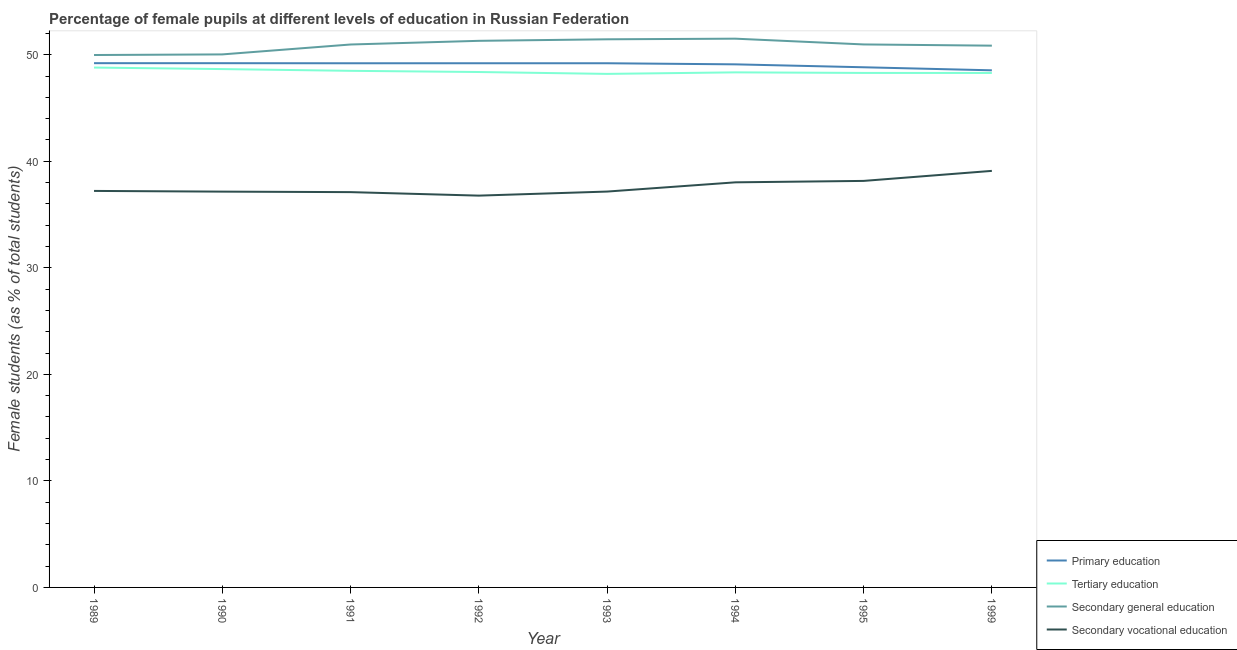How many different coloured lines are there?
Your response must be concise. 4. Does the line corresponding to percentage of female students in secondary vocational education intersect with the line corresponding to percentage of female students in secondary education?
Give a very brief answer. No. What is the percentage of female students in secondary vocational education in 1999?
Keep it short and to the point. 39.1. Across all years, what is the maximum percentage of female students in primary education?
Your answer should be compact. 49.21. Across all years, what is the minimum percentage of female students in secondary education?
Your answer should be compact. 49.97. In which year was the percentage of female students in secondary education maximum?
Your answer should be very brief. 1994. In which year was the percentage of female students in secondary education minimum?
Your answer should be very brief. 1989. What is the total percentage of female students in primary education in the graph?
Make the answer very short. 392.46. What is the difference between the percentage of female students in secondary vocational education in 1989 and that in 1995?
Your answer should be compact. -0.94. What is the difference between the percentage of female students in tertiary education in 1991 and the percentage of female students in secondary education in 1994?
Ensure brevity in your answer.  -3.02. What is the average percentage of female students in secondary education per year?
Ensure brevity in your answer.  50.88. In the year 1992, what is the difference between the percentage of female students in tertiary education and percentage of female students in secondary vocational education?
Ensure brevity in your answer.  11.6. In how many years, is the percentage of female students in secondary vocational education greater than 4 %?
Your answer should be compact. 8. What is the ratio of the percentage of female students in secondary vocational education in 1989 to that in 1994?
Offer a very short reply. 0.98. Is the percentage of female students in secondary education in 1991 less than that in 1992?
Keep it short and to the point. Yes. What is the difference between the highest and the second highest percentage of female students in secondary education?
Make the answer very short. 0.06. What is the difference between the highest and the lowest percentage of female students in primary education?
Your answer should be very brief. 0.67. Is the sum of the percentage of female students in tertiary education in 1993 and 1995 greater than the maximum percentage of female students in primary education across all years?
Provide a short and direct response. Yes. Is it the case that in every year, the sum of the percentage of female students in primary education and percentage of female students in tertiary education is greater than the percentage of female students in secondary education?
Give a very brief answer. Yes. Does the percentage of female students in primary education monotonically increase over the years?
Make the answer very short. No. How many years are there in the graph?
Your answer should be compact. 8. Are the values on the major ticks of Y-axis written in scientific E-notation?
Keep it short and to the point. No. How are the legend labels stacked?
Make the answer very short. Vertical. What is the title of the graph?
Keep it short and to the point. Percentage of female pupils at different levels of education in Russian Federation. What is the label or title of the Y-axis?
Provide a succinct answer. Female students (as % of total students). What is the Female students (as % of total students) of Primary education in 1989?
Keep it short and to the point. 49.21. What is the Female students (as % of total students) in Tertiary education in 1989?
Your response must be concise. 48.79. What is the Female students (as % of total students) of Secondary general education in 1989?
Ensure brevity in your answer.  49.97. What is the Female students (as % of total students) of Secondary vocational education in 1989?
Offer a very short reply. 37.21. What is the Female students (as % of total students) of Primary education in 1990?
Your answer should be very brief. 49.2. What is the Female students (as % of total students) of Tertiary education in 1990?
Your response must be concise. 48.65. What is the Female students (as % of total students) of Secondary general education in 1990?
Provide a succinct answer. 50.03. What is the Female students (as % of total students) of Secondary vocational education in 1990?
Make the answer very short. 37.15. What is the Female students (as % of total students) in Primary education in 1991?
Offer a terse response. 49.2. What is the Female students (as % of total students) in Tertiary education in 1991?
Provide a succinct answer. 48.49. What is the Female students (as % of total students) in Secondary general education in 1991?
Your response must be concise. 50.96. What is the Female students (as % of total students) of Secondary vocational education in 1991?
Keep it short and to the point. 37.1. What is the Female students (as % of total students) of Primary education in 1992?
Offer a terse response. 49.2. What is the Female students (as % of total students) in Tertiary education in 1992?
Offer a terse response. 48.38. What is the Female students (as % of total students) in Secondary general education in 1992?
Provide a succinct answer. 51.3. What is the Female students (as % of total students) in Secondary vocational education in 1992?
Your answer should be compact. 36.77. What is the Female students (as % of total students) in Primary education in 1993?
Provide a short and direct response. 49.2. What is the Female students (as % of total students) of Tertiary education in 1993?
Give a very brief answer. 48.2. What is the Female students (as % of total students) in Secondary general education in 1993?
Ensure brevity in your answer.  51.45. What is the Female students (as % of total students) of Secondary vocational education in 1993?
Make the answer very short. 37.15. What is the Female students (as % of total students) in Primary education in 1994?
Provide a succinct answer. 49.1. What is the Female students (as % of total students) in Tertiary education in 1994?
Offer a very short reply. 48.34. What is the Female students (as % of total students) of Secondary general education in 1994?
Offer a terse response. 51.51. What is the Female students (as % of total students) of Secondary vocational education in 1994?
Ensure brevity in your answer.  38.02. What is the Female students (as % of total students) of Primary education in 1995?
Your answer should be compact. 48.82. What is the Female students (as % of total students) of Tertiary education in 1995?
Offer a terse response. 48.29. What is the Female students (as % of total students) in Secondary general education in 1995?
Give a very brief answer. 50.96. What is the Female students (as % of total students) of Secondary vocational education in 1995?
Ensure brevity in your answer.  38.16. What is the Female students (as % of total students) in Primary education in 1999?
Your answer should be very brief. 48.54. What is the Female students (as % of total students) of Tertiary education in 1999?
Offer a terse response. 48.29. What is the Female students (as % of total students) in Secondary general education in 1999?
Ensure brevity in your answer.  50.85. What is the Female students (as % of total students) in Secondary vocational education in 1999?
Give a very brief answer. 39.1. Across all years, what is the maximum Female students (as % of total students) in Primary education?
Offer a very short reply. 49.21. Across all years, what is the maximum Female students (as % of total students) in Tertiary education?
Your answer should be very brief. 48.79. Across all years, what is the maximum Female students (as % of total students) in Secondary general education?
Keep it short and to the point. 51.51. Across all years, what is the maximum Female students (as % of total students) in Secondary vocational education?
Provide a short and direct response. 39.1. Across all years, what is the minimum Female students (as % of total students) in Primary education?
Make the answer very short. 48.54. Across all years, what is the minimum Female students (as % of total students) in Tertiary education?
Your answer should be very brief. 48.2. Across all years, what is the minimum Female students (as % of total students) of Secondary general education?
Make the answer very short. 49.97. Across all years, what is the minimum Female students (as % of total students) of Secondary vocational education?
Offer a very short reply. 36.77. What is the total Female students (as % of total students) in Primary education in the graph?
Ensure brevity in your answer.  392.46. What is the total Female students (as % of total students) in Tertiary education in the graph?
Your answer should be very brief. 387.43. What is the total Female students (as % of total students) in Secondary general education in the graph?
Your answer should be very brief. 407.03. What is the total Female students (as % of total students) of Secondary vocational education in the graph?
Offer a terse response. 300.67. What is the difference between the Female students (as % of total students) in Primary education in 1989 and that in 1990?
Your response must be concise. 0. What is the difference between the Female students (as % of total students) in Tertiary education in 1989 and that in 1990?
Your answer should be very brief. 0.14. What is the difference between the Female students (as % of total students) in Secondary general education in 1989 and that in 1990?
Give a very brief answer. -0.06. What is the difference between the Female students (as % of total students) in Secondary vocational education in 1989 and that in 1990?
Give a very brief answer. 0.07. What is the difference between the Female students (as % of total students) of Primary education in 1989 and that in 1991?
Your answer should be compact. 0.01. What is the difference between the Female students (as % of total students) in Tertiary education in 1989 and that in 1991?
Give a very brief answer. 0.31. What is the difference between the Female students (as % of total students) in Secondary general education in 1989 and that in 1991?
Offer a terse response. -0.99. What is the difference between the Female students (as % of total students) of Secondary vocational education in 1989 and that in 1991?
Make the answer very short. 0.11. What is the difference between the Female students (as % of total students) of Primary education in 1989 and that in 1992?
Your answer should be compact. 0.01. What is the difference between the Female students (as % of total students) of Tertiary education in 1989 and that in 1992?
Provide a short and direct response. 0.42. What is the difference between the Female students (as % of total students) in Secondary general education in 1989 and that in 1992?
Make the answer very short. -1.33. What is the difference between the Female students (as % of total students) of Secondary vocational education in 1989 and that in 1992?
Make the answer very short. 0.44. What is the difference between the Female students (as % of total students) in Primary education in 1989 and that in 1993?
Keep it short and to the point. 0.01. What is the difference between the Female students (as % of total students) in Tertiary education in 1989 and that in 1993?
Give a very brief answer. 0.59. What is the difference between the Female students (as % of total students) of Secondary general education in 1989 and that in 1993?
Keep it short and to the point. -1.48. What is the difference between the Female students (as % of total students) in Secondary vocational education in 1989 and that in 1993?
Keep it short and to the point. 0.06. What is the difference between the Female students (as % of total students) in Primary education in 1989 and that in 1994?
Your response must be concise. 0.11. What is the difference between the Female students (as % of total students) of Tertiary education in 1989 and that in 1994?
Offer a very short reply. 0.45. What is the difference between the Female students (as % of total students) in Secondary general education in 1989 and that in 1994?
Keep it short and to the point. -1.53. What is the difference between the Female students (as % of total students) of Secondary vocational education in 1989 and that in 1994?
Provide a succinct answer. -0.81. What is the difference between the Female students (as % of total students) of Primary education in 1989 and that in 1995?
Give a very brief answer. 0.38. What is the difference between the Female students (as % of total students) in Tertiary education in 1989 and that in 1995?
Provide a succinct answer. 0.5. What is the difference between the Female students (as % of total students) of Secondary general education in 1989 and that in 1995?
Provide a short and direct response. -0.99. What is the difference between the Female students (as % of total students) in Secondary vocational education in 1989 and that in 1995?
Provide a succinct answer. -0.94. What is the difference between the Female students (as % of total students) of Primary education in 1989 and that in 1999?
Offer a terse response. 0.67. What is the difference between the Female students (as % of total students) in Tertiary education in 1989 and that in 1999?
Offer a terse response. 0.51. What is the difference between the Female students (as % of total students) in Secondary general education in 1989 and that in 1999?
Your answer should be compact. -0.88. What is the difference between the Female students (as % of total students) of Secondary vocational education in 1989 and that in 1999?
Give a very brief answer. -1.88. What is the difference between the Female students (as % of total students) in Primary education in 1990 and that in 1991?
Your response must be concise. 0.01. What is the difference between the Female students (as % of total students) in Tertiary education in 1990 and that in 1991?
Your response must be concise. 0.16. What is the difference between the Female students (as % of total students) of Secondary general education in 1990 and that in 1991?
Provide a succinct answer. -0.93. What is the difference between the Female students (as % of total students) in Secondary vocational education in 1990 and that in 1991?
Make the answer very short. 0.05. What is the difference between the Female students (as % of total students) in Primary education in 1990 and that in 1992?
Your answer should be compact. 0. What is the difference between the Female students (as % of total students) in Tertiary education in 1990 and that in 1992?
Offer a very short reply. 0.28. What is the difference between the Female students (as % of total students) of Secondary general education in 1990 and that in 1992?
Make the answer very short. -1.27. What is the difference between the Female students (as % of total students) of Secondary vocational education in 1990 and that in 1992?
Provide a succinct answer. 0.38. What is the difference between the Female students (as % of total students) of Primary education in 1990 and that in 1993?
Your answer should be very brief. 0.01. What is the difference between the Female students (as % of total students) of Tertiary education in 1990 and that in 1993?
Make the answer very short. 0.45. What is the difference between the Female students (as % of total students) of Secondary general education in 1990 and that in 1993?
Your answer should be compact. -1.42. What is the difference between the Female students (as % of total students) in Secondary vocational education in 1990 and that in 1993?
Give a very brief answer. -0.01. What is the difference between the Female students (as % of total students) in Primary education in 1990 and that in 1994?
Your response must be concise. 0.11. What is the difference between the Female students (as % of total students) of Tertiary education in 1990 and that in 1994?
Your answer should be very brief. 0.31. What is the difference between the Female students (as % of total students) of Secondary general education in 1990 and that in 1994?
Offer a terse response. -1.48. What is the difference between the Female students (as % of total students) in Secondary vocational education in 1990 and that in 1994?
Ensure brevity in your answer.  -0.87. What is the difference between the Female students (as % of total students) in Primary education in 1990 and that in 1995?
Your response must be concise. 0.38. What is the difference between the Female students (as % of total students) in Tertiary education in 1990 and that in 1995?
Ensure brevity in your answer.  0.36. What is the difference between the Female students (as % of total students) of Secondary general education in 1990 and that in 1995?
Give a very brief answer. -0.94. What is the difference between the Female students (as % of total students) in Secondary vocational education in 1990 and that in 1995?
Keep it short and to the point. -1.01. What is the difference between the Female students (as % of total students) of Primary education in 1990 and that in 1999?
Your answer should be compact. 0.67. What is the difference between the Female students (as % of total students) of Tertiary education in 1990 and that in 1999?
Keep it short and to the point. 0.36. What is the difference between the Female students (as % of total students) of Secondary general education in 1990 and that in 1999?
Give a very brief answer. -0.82. What is the difference between the Female students (as % of total students) in Secondary vocational education in 1990 and that in 1999?
Give a very brief answer. -1.95. What is the difference between the Female students (as % of total students) of Primary education in 1991 and that in 1992?
Provide a short and direct response. -0. What is the difference between the Female students (as % of total students) in Tertiary education in 1991 and that in 1992?
Make the answer very short. 0.11. What is the difference between the Female students (as % of total students) in Secondary general education in 1991 and that in 1992?
Provide a short and direct response. -0.34. What is the difference between the Female students (as % of total students) in Secondary vocational education in 1991 and that in 1992?
Your response must be concise. 0.33. What is the difference between the Female students (as % of total students) of Primary education in 1991 and that in 1993?
Give a very brief answer. -0. What is the difference between the Female students (as % of total students) of Tertiary education in 1991 and that in 1993?
Offer a very short reply. 0.29. What is the difference between the Female students (as % of total students) in Secondary general education in 1991 and that in 1993?
Offer a very short reply. -0.49. What is the difference between the Female students (as % of total students) of Secondary vocational education in 1991 and that in 1993?
Offer a terse response. -0.05. What is the difference between the Female students (as % of total students) of Primary education in 1991 and that in 1994?
Provide a succinct answer. 0.1. What is the difference between the Female students (as % of total students) of Tertiary education in 1991 and that in 1994?
Provide a succinct answer. 0.14. What is the difference between the Female students (as % of total students) of Secondary general education in 1991 and that in 1994?
Provide a short and direct response. -0.55. What is the difference between the Female students (as % of total students) in Secondary vocational education in 1991 and that in 1994?
Your response must be concise. -0.92. What is the difference between the Female students (as % of total students) of Primary education in 1991 and that in 1995?
Your response must be concise. 0.38. What is the difference between the Female students (as % of total students) in Tertiary education in 1991 and that in 1995?
Offer a terse response. 0.2. What is the difference between the Female students (as % of total students) of Secondary general education in 1991 and that in 1995?
Provide a short and direct response. -0.01. What is the difference between the Female students (as % of total students) in Secondary vocational education in 1991 and that in 1995?
Offer a very short reply. -1.05. What is the difference between the Female students (as % of total students) in Primary education in 1991 and that in 1999?
Offer a very short reply. 0.66. What is the difference between the Female students (as % of total students) of Tertiary education in 1991 and that in 1999?
Keep it short and to the point. 0.2. What is the difference between the Female students (as % of total students) of Secondary general education in 1991 and that in 1999?
Give a very brief answer. 0.11. What is the difference between the Female students (as % of total students) in Secondary vocational education in 1991 and that in 1999?
Your answer should be compact. -1.99. What is the difference between the Female students (as % of total students) in Tertiary education in 1992 and that in 1993?
Your response must be concise. 0.18. What is the difference between the Female students (as % of total students) of Secondary general education in 1992 and that in 1993?
Keep it short and to the point. -0.14. What is the difference between the Female students (as % of total students) in Secondary vocational education in 1992 and that in 1993?
Make the answer very short. -0.38. What is the difference between the Female students (as % of total students) of Primary education in 1992 and that in 1994?
Your answer should be very brief. 0.1. What is the difference between the Female students (as % of total students) of Tertiary education in 1992 and that in 1994?
Make the answer very short. 0.03. What is the difference between the Female students (as % of total students) of Secondary general education in 1992 and that in 1994?
Your answer should be compact. -0.2. What is the difference between the Female students (as % of total students) of Secondary vocational education in 1992 and that in 1994?
Your response must be concise. -1.25. What is the difference between the Female students (as % of total students) in Primary education in 1992 and that in 1995?
Provide a short and direct response. 0.38. What is the difference between the Female students (as % of total students) in Tertiary education in 1992 and that in 1995?
Provide a short and direct response. 0.09. What is the difference between the Female students (as % of total students) of Secondary general education in 1992 and that in 1995?
Your answer should be compact. 0.34. What is the difference between the Female students (as % of total students) of Secondary vocational education in 1992 and that in 1995?
Provide a succinct answer. -1.38. What is the difference between the Female students (as % of total students) of Primary education in 1992 and that in 1999?
Your response must be concise. 0.66. What is the difference between the Female students (as % of total students) in Tertiary education in 1992 and that in 1999?
Make the answer very short. 0.09. What is the difference between the Female students (as % of total students) in Secondary general education in 1992 and that in 1999?
Offer a terse response. 0.45. What is the difference between the Female students (as % of total students) of Secondary vocational education in 1992 and that in 1999?
Provide a succinct answer. -2.32. What is the difference between the Female students (as % of total students) in Primary education in 1993 and that in 1994?
Your response must be concise. 0.1. What is the difference between the Female students (as % of total students) in Tertiary education in 1993 and that in 1994?
Provide a short and direct response. -0.14. What is the difference between the Female students (as % of total students) of Secondary general education in 1993 and that in 1994?
Your answer should be compact. -0.06. What is the difference between the Female students (as % of total students) of Secondary vocational education in 1993 and that in 1994?
Offer a terse response. -0.87. What is the difference between the Female students (as % of total students) of Primary education in 1993 and that in 1995?
Provide a succinct answer. 0.38. What is the difference between the Female students (as % of total students) of Tertiary education in 1993 and that in 1995?
Keep it short and to the point. -0.09. What is the difference between the Female students (as % of total students) of Secondary general education in 1993 and that in 1995?
Your response must be concise. 0.48. What is the difference between the Female students (as % of total students) of Secondary vocational education in 1993 and that in 1995?
Your answer should be very brief. -1. What is the difference between the Female students (as % of total students) in Primary education in 1993 and that in 1999?
Your response must be concise. 0.66. What is the difference between the Female students (as % of total students) of Tertiary education in 1993 and that in 1999?
Give a very brief answer. -0.09. What is the difference between the Female students (as % of total students) of Secondary general education in 1993 and that in 1999?
Your answer should be very brief. 0.6. What is the difference between the Female students (as % of total students) in Secondary vocational education in 1993 and that in 1999?
Your answer should be very brief. -1.94. What is the difference between the Female students (as % of total students) in Primary education in 1994 and that in 1995?
Make the answer very short. 0.27. What is the difference between the Female students (as % of total students) of Tertiary education in 1994 and that in 1995?
Your response must be concise. 0.05. What is the difference between the Female students (as % of total students) of Secondary general education in 1994 and that in 1995?
Ensure brevity in your answer.  0.54. What is the difference between the Female students (as % of total students) of Secondary vocational education in 1994 and that in 1995?
Offer a very short reply. -0.13. What is the difference between the Female students (as % of total students) of Primary education in 1994 and that in 1999?
Ensure brevity in your answer.  0.56. What is the difference between the Female students (as % of total students) in Tertiary education in 1994 and that in 1999?
Offer a very short reply. 0.06. What is the difference between the Female students (as % of total students) in Secondary general education in 1994 and that in 1999?
Keep it short and to the point. 0.66. What is the difference between the Female students (as % of total students) in Secondary vocational education in 1994 and that in 1999?
Ensure brevity in your answer.  -1.08. What is the difference between the Female students (as % of total students) of Primary education in 1995 and that in 1999?
Provide a short and direct response. 0.29. What is the difference between the Female students (as % of total students) of Tertiary education in 1995 and that in 1999?
Provide a short and direct response. 0. What is the difference between the Female students (as % of total students) in Secondary general education in 1995 and that in 1999?
Make the answer very short. 0.11. What is the difference between the Female students (as % of total students) of Secondary vocational education in 1995 and that in 1999?
Your answer should be very brief. -0.94. What is the difference between the Female students (as % of total students) in Primary education in 1989 and the Female students (as % of total students) in Tertiary education in 1990?
Give a very brief answer. 0.56. What is the difference between the Female students (as % of total students) of Primary education in 1989 and the Female students (as % of total students) of Secondary general education in 1990?
Your answer should be compact. -0.82. What is the difference between the Female students (as % of total students) in Primary education in 1989 and the Female students (as % of total students) in Secondary vocational education in 1990?
Provide a succinct answer. 12.06. What is the difference between the Female students (as % of total students) of Tertiary education in 1989 and the Female students (as % of total students) of Secondary general education in 1990?
Make the answer very short. -1.23. What is the difference between the Female students (as % of total students) of Tertiary education in 1989 and the Female students (as % of total students) of Secondary vocational education in 1990?
Offer a very short reply. 11.65. What is the difference between the Female students (as % of total students) in Secondary general education in 1989 and the Female students (as % of total students) in Secondary vocational education in 1990?
Provide a short and direct response. 12.82. What is the difference between the Female students (as % of total students) in Primary education in 1989 and the Female students (as % of total students) in Tertiary education in 1991?
Your answer should be very brief. 0.72. What is the difference between the Female students (as % of total students) of Primary education in 1989 and the Female students (as % of total students) of Secondary general education in 1991?
Make the answer very short. -1.75. What is the difference between the Female students (as % of total students) of Primary education in 1989 and the Female students (as % of total students) of Secondary vocational education in 1991?
Offer a very short reply. 12.1. What is the difference between the Female students (as % of total students) in Tertiary education in 1989 and the Female students (as % of total students) in Secondary general education in 1991?
Your answer should be very brief. -2.16. What is the difference between the Female students (as % of total students) of Tertiary education in 1989 and the Female students (as % of total students) of Secondary vocational education in 1991?
Offer a very short reply. 11.69. What is the difference between the Female students (as % of total students) in Secondary general education in 1989 and the Female students (as % of total students) in Secondary vocational education in 1991?
Your answer should be very brief. 12.87. What is the difference between the Female students (as % of total students) of Primary education in 1989 and the Female students (as % of total students) of Tertiary education in 1992?
Keep it short and to the point. 0.83. What is the difference between the Female students (as % of total students) in Primary education in 1989 and the Female students (as % of total students) in Secondary general education in 1992?
Provide a succinct answer. -2.1. What is the difference between the Female students (as % of total students) in Primary education in 1989 and the Female students (as % of total students) in Secondary vocational education in 1992?
Keep it short and to the point. 12.43. What is the difference between the Female students (as % of total students) of Tertiary education in 1989 and the Female students (as % of total students) of Secondary general education in 1992?
Your response must be concise. -2.51. What is the difference between the Female students (as % of total students) in Tertiary education in 1989 and the Female students (as % of total students) in Secondary vocational education in 1992?
Give a very brief answer. 12.02. What is the difference between the Female students (as % of total students) of Secondary general education in 1989 and the Female students (as % of total students) of Secondary vocational education in 1992?
Make the answer very short. 13.2. What is the difference between the Female students (as % of total students) in Primary education in 1989 and the Female students (as % of total students) in Tertiary education in 1993?
Provide a short and direct response. 1.01. What is the difference between the Female students (as % of total students) in Primary education in 1989 and the Female students (as % of total students) in Secondary general education in 1993?
Give a very brief answer. -2.24. What is the difference between the Female students (as % of total students) of Primary education in 1989 and the Female students (as % of total students) of Secondary vocational education in 1993?
Provide a succinct answer. 12.05. What is the difference between the Female students (as % of total students) of Tertiary education in 1989 and the Female students (as % of total students) of Secondary general education in 1993?
Your answer should be compact. -2.65. What is the difference between the Female students (as % of total students) in Tertiary education in 1989 and the Female students (as % of total students) in Secondary vocational education in 1993?
Provide a succinct answer. 11.64. What is the difference between the Female students (as % of total students) of Secondary general education in 1989 and the Female students (as % of total students) of Secondary vocational education in 1993?
Offer a very short reply. 12.82. What is the difference between the Female students (as % of total students) of Primary education in 1989 and the Female students (as % of total students) of Tertiary education in 1994?
Your answer should be very brief. 0.86. What is the difference between the Female students (as % of total students) of Primary education in 1989 and the Female students (as % of total students) of Secondary general education in 1994?
Offer a very short reply. -2.3. What is the difference between the Female students (as % of total students) of Primary education in 1989 and the Female students (as % of total students) of Secondary vocational education in 1994?
Ensure brevity in your answer.  11.18. What is the difference between the Female students (as % of total students) in Tertiary education in 1989 and the Female students (as % of total students) in Secondary general education in 1994?
Keep it short and to the point. -2.71. What is the difference between the Female students (as % of total students) of Tertiary education in 1989 and the Female students (as % of total students) of Secondary vocational education in 1994?
Your answer should be very brief. 10.77. What is the difference between the Female students (as % of total students) in Secondary general education in 1989 and the Female students (as % of total students) in Secondary vocational education in 1994?
Provide a succinct answer. 11.95. What is the difference between the Female students (as % of total students) in Primary education in 1989 and the Female students (as % of total students) in Tertiary education in 1995?
Offer a terse response. 0.92. What is the difference between the Female students (as % of total students) in Primary education in 1989 and the Female students (as % of total students) in Secondary general education in 1995?
Make the answer very short. -1.76. What is the difference between the Female students (as % of total students) of Primary education in 1989 and the Female students (as % of total students) of Secondary vocational education in 1995?
Make the answer very short. 11.05. What is the difference between the Female students (as % of total students) in Tertiary education in 1989 and the Female students (as % of total students) in Secondary general education in 1995?
Offer a terse response. -2.17. What is the difference between the Female students (as % of total students) in Tertiary education in 1989 and the Female students (as % of total students) in Secondary vocational education in 1995?
Keep it short and to the point. 10.64. What is the difference between the Female students (as % of total students) of Secondary general education in 1989 and the Female students (as % of total students) of Secondary vocational education in 1995?
Provide a short and direct response. 11.82. What is the difference between the Female students (as % of total students) of Primary education in 1989 and the Female students (as % of total students) of Tertiary education in 1999?
Make the answer very short. 0.92. What is the difference between the Female students (as % of total students) in Primary education in 1989 and the Female students (as % of total students) in Secondary general education in 1999?
Offer a very short reply. -1.64. What is the difference between the Female students (as % of total students) in Primary education in 1989 and the Female students (as % of total students) in Secondary vocational education in 1999?
Offer a terse response. 10.11. What is the difference between the Female students (as % of total students) in Tertiary education in 1989 and the Female students (as % of total students) in Secondary general education in 1999?
Provide a short and direct response. -2.06. What is the difference between the Female students (as % of total students) in Tertiary education in 1989 and the Female students (as % of total students) in Secondary vocational education in 1999?
Offer a terse response. 9.7. What is the difference between the Female students (as % of total students) in Secondary general education in 1989 and the Female students (as % of total students) in Secondary vocational education in 1999?
Give a very brief answer. 10.87. What is the difference between the Female students (as % of total students) of Primary education in 1990 and the Female students (as % of total students) of Tertiary education in 1991?
Ensure brevity in your answer.  0.72. What is the difference between the Female students (as % of total students) of Primary education in 1990 and the Female students (as % of total students) of Secondary general education in 1991?
Keep it short and to the point. -1.75. What is the difference between the Female students (as % of total students) of Primary education in 1990 and the Female students (as % of total students) of Secondary vocational education in 1991?
Ensure brevity in your answer.  12.1. What is the difference between the Female students (as % of total students) of Tertiary education in 1990 and the Female students (as % of total students) of Secondary general education in 1991?
Keep it short and to the point. -2.31. What is the difference between the Female students (as % of total students) in Tertiary education in 1990 and the Female students (as % of total students) in Secondary vocational education in 1991?
Keep it short and to the point. 11.55. What is the difference between the Female students (as % of total students) in Secondary general education in 1990 and the Female students (as % of total students) in Secondary vocational education in 1991?
Give a very brief answer. 12.93. What is the difference between the Female students (as % of total students) of Primary education in 1990 and the Female students (as % of total students) of Tertiary education in 1992?
Your response must be concise. 0.83. What is the difference between the Female students (as % of total students) in Primary education in 1990 and the Female students (as % of total students) in Secondary vocational education in 1992?
Your answer should be very brief. 12.43. What is the difference between the Female students (as % of total students) of Tertiary education in 1990 and the Female students (as % of total students) of Secondary general education in 1992?
Ensure brevity in your answer.  -2.65. What is the difference between the Female students (as % of total students) of Tertiary education in 1990 and the Female students (as % of total students) of Secondary vocational education in 1992?
Offer a very short reply. 11.88. What is the difference between the Female students (as % of total students) of Secondary general education in 1990 and the Female students (as % of total students) of Secondary vocational education in 1992?
Provide a succinct answer. 13.26. What is the difference between the Female students (as % of total students) in Primary education in 1990 and the Female students (as % of total students) in Secondary general education in 1993?
Ensure brevity in your answer.  -2.24. What is the difference between the Female students (as % of total students) of Primary education in 1990 and the Female students (as % of total students) of Secondary vocational education in 1993?
Provide a short and direct response. 12.05. What is the difference between the Female students (as % of total students) of Tertiary education in 1990 and the Female students (as % of total students) of Secondary general education in 1993?
Offer a terse response. -2.8. What is the difference between the Female students (as % of total students) of Tertiary education in 1990 and the Female students (as % of total students) of Secondary vocational education in 1993?
Give a very brief answer. 11.5. What is the difference between the Female students (as % of total students) of Secondary general education in 1990 and the Female students (as % of total students) of Secondary vocational education in 1993?
Give a very brief answer. 12.87. What is the difference between the Female students (as % of total students) in Primary education in 1990 and the Female students (as % of total students) in Tertiary education in 1994?
Your response must be concise. 0.86. What is the difference between the Female students (as % of total students) in Primary education in 1990 and the Female students (as % of total students) in Secondary general education in 1994?
Keep it short and to the point. -2.3. What is the difference between the Female students (as % of total students) in Primary education in 1990 and the Female students (as % of total students) in Secondary vocational education in 1994?
Your answer should be compact. 11.18. What is the difference between the Female students (as % of total students) in Tertiary education in 1990 and the Female students (as % of total students) in Secondary general education in 1994?
Your answer should be very brief. -2.85. What is the difference between the Female students (as % of total students) in Tertiary education in 1990 and the Female students (as % of total students) in Secondary vocational education in 1994?
Your answer should be very brief. 10.63. What is the difference between the Female students (as % of total students) of Secondary general education in 1990 and the Female students (as % of total students) of Secondary vocational education in 1994?
Provide a succinct answer. 12.01. What is the difference between the Female students (as % of total students) of Primary education in 1990 and the Female students (as % of total students) of Tertiary education in 1995?
Offer a very short reply. 0.91. What is the difference between the Female students (as % of total students) of Primary education in 1990 and the Female students (as % of total students) of Secondary general education in 1995?
Your answer should be very brief. -1.76. What is the difference between the Female students (as % of total students) of Primary education in 1990 and the Female students (as % of total students) of Secondary vocational education in 1995?
Your answer should be very brief. 11.05. What is the difference between the Female students (as % of total students) in Tertiary education in 1990 and the Female students (as % of total students) in Secondary general education in 1995?
Your response must be concise. -2.31. What is the difference between the Female students (as % of total students) in Tertiary education in 1990 and the Female students (as % of total students) in Secondary vocational education in 1995?
Offer a very short reply. 10.5. What is the difference between the Female students (as % of total students) in Secondary general education in 1990 and the Female students (as % of total students) in Secondary vocational education in 1995?
Offer a terse response. 11.87. What is the difference between the Female students (as % of total students) in Primary education in 1990 and the Female students (as % of total students) in Tertiary education in 1999?
Make the answer very short. 0.92. What is the difference between the Female students (as % of total students) in Primary education in 1990 and the Female students (as % of total students) in Secondary general education in 1999?
Provide a short and direct response. -1.65. What is the difference between the Female students (as % of total students) of Primary education in 1990 and the Female students (as % of total students) of Secondary vocational education in 1999?
Offer a terse response. 10.11. What is the difference between the Female students (as % of total students) in Tertiary education in 1990 and the Female students (as % of total students) in Secondary general education in 1999?
Give a very brief answer. -2.2. What is the difference between the Female students (as % of total students) of Tertiary education in 1990 and the Female students (as % of total students) of Secondary vocational education in 1999?
Give a very brief answer. 9.55. What is the difference between the Female students (as % of total students) of Secondary general education in 1990 and the Female students (as % of total students) of Secondary vocational education in 1999?
Provide a succinct answer. 10.93. What is the difference between the Female students (as % of total students) of Primary education in 1991 and the Female students (as % of total students) of Tertiary education in 1992?
Offer a terse response. 0.82. What is the difference between the Female students (as % of total students) of Primary education in 1991 and the Female students (as % of total students) of Secondary general education in 1992?
Offer a terse response. -2.11. What is the difference between the Female students (as % of total students) of Primary education in 1991 and the Female students (as % of total students) of Secondary vocational education in 1992?
Make the answer very short. 12.42. What is the difference between the Female students (as % of total students) of Tertiary education in 1991 and the Female students (as % of total students) of Secondary general education in 1992?
Keep it short and to the point. -2.82. What is the difference between the Female students (as % of total students) in Tertiary education in 1991 and the Female students (as % of total students) in Secondary vocational education in 1992?
Provide a succinct answer. 11.71. What is the difference between the Female students (as % of total students) in Secondary general education in 1991 and the Female students (as % of total students) in Secondary vocational education in 1992?
Offer a terse response. 14.19. What is the difference between the Female students (as % of total students) in Primary education in 1991 and the Female students (as % of total students) in Tertiary education in 1993?
Make the answer very short. 1. What is the difference between the Female students (as % of total students) of Primary education in 1991 and the Female students (as % of total students) of Secondary general education in 1993?
Give a very brief answer. -2.25. What is the difference between the Female students (as % of total students) in Primary education in 1991 and the Female students (as % of total students) in Secondary vocational education in 1993?
Keep it short and to the point. 12.04. What is the difference between the Female students (as % of total students) in Tertiary education in 1991 and the Female students (as % of total students) in Secondary general education in 1993?
Provide a succinct answer. -2.96. What is the difference between the Female students (as % of total students) of Tertiary education in 1991 and the Female students (as % of total students) of Secondary vocational education in 1993?
Provide a short and direct response. 11.33. What is the difference between the Female students (as % of total students) of Secondary general education in 1991 and the Female students (as % of total students) of Secondary vocational education in 1993?
Offer a terse response. 13.8. What is the difference between the Female students (as % of total students) in Primary education in 1991 and the Female students (as % of total students) in Tertiary education in 1994?
Provide a succinct answer. 0.85. What is the difference between the Female students (as % of total students) in Primary education in 1991 and the Female students (as % of total students) in Secondary general education in 1994?
Your answer should be compact. -2.31. What is the difference between the Female students (as % of total students) of Primary education in 1991 and the Female students (as % of total students) of Secondary vocational education in 1994?
Give a very brief answer. 11.18. What is the difference between the Female students (as % of total students) of Tertiary education in 1991 and the Female students (as % of total students) of Secondary general education in 1994?
Your answer should be compact. -3.02. What is the difference between the Female students (as % of total students) in Tertiary education in 1991 and the Female students (as % of total students) in Secondary vocational education in 1994?
Offer a terse response. 10.47. What is the difference between the Female students (as % of total students) of Secondary general education in 1991 and the Female students (as % of total students) of Secondary vocational education in 1994?
Provide a succinct answer. 12.94. What is the difference between the Female students (as % of total students) of Primary education in 1991 and the Female students (as % of total students) of Tertiary education in 1995?
Offer a very short reply. 0.91. What is the difference between the Female students (as % of total students) in Primary education in 1991 and the Female students (as % of total students) in Secondary general education in 1995?
Ensure brevity in your answer.  -1.77. What is the difference between the Female students (as % of total students) of Primary education in 1991 and the Female students (as % of total students) of Secondary vocational education in 1995?
Provide a succinct answer. 11.04. What is the difference between the Female students (as % of total students) in Tertiary education in 1991 and the Female students (as % of total students) in Secondary general education in 1995?
Provide a succinct answer. -2.48. What is the difference between the Female students (as % of total students) of Tertiary education in 1991 and the Female students (as % of total students) of Secondary vocational education in 1995?
Ensure brevity in your answer.  10.33. What is the difference between the Female students (as % of total students) in Secondary general education in 1991 and the Female students (as % of total students) in Secondary vocational education in 1995?
Your answer should be compact. 12.8. What is the difference between the Female students (as % of total students) of Primary education in 1991 and the Female students (as % of total students) of Tertiary education in 1999?
Your answer should be compact. 0.91. What is the difference between the Female students (as % of total students) of Primary education in 1991 and the Female students (as % of total students) of Secondary general education in 1999?
Provide a short and direct response. -1.65. What is the difference between the Female students (as % of total students) of Primary education in 1991 and the Female students (as % of total students) of Secondary vocational education in 1999?
Your answer should be very brief. 10.1. What is the difference between the Female students (as % of total students) in Tertiary education in 1991 and the Female students (as % of total students) in Secondary general education in 1999?
Provide a succinct answer. -2.36. What is the difference between the Female students (as % of total students) of Tertiary education in 1991 and the Female students (as % of total students) of Secondary vocational education in 1999?
Ensure brevity in your answer.  9.39. What is the difference between the Female students (as % of total students) of Secondary general education in 1991 and the Female students (as % of total students) of Secondary vocational education in 1999?
Keep it short and to the point. 11.86. What is the difference between the Female students (as % of total students) in Primary education in 1992 and the Female students (as % of total students) in Tertiary education in 1993?
Provide a short and direct response. 1. What is the difference between the Female students (as % of total students) in Primary education in 1992 and the Female students (as % of total students) in Secondary general education in 1993?
Make the answer very short. -2.25. What is the difference between the Female students (as % of total students) of Primary education in 1992 and the Female students (as % of total students) of Secondary vocational education in 1993?
Provide a short and direct response. 12.04. What is the difference between the Female students (as % of total students) in Tertiary education in 1992 and the Female students (as % of total students) in Secondary general education in 1993?
Keep it short and to the point. -3.07. What is the difference between the Female students (as % of total students) of Tertiary education in 1992 and the Female students (as % of total students) of Secondary vocational education in 1993?
Provide a short and direct response. 11.22. What is the difference between the Female students (as % of total students) of Secondary general education in 1992 and the Female students (as % of total students) of Secondary vocational education in 1993?
Your answer should be compact. 14.15. What is the difference between the Female students (as % of total students) of Primary education in 1992 and the Female students (as % of total students) of Tertiary education in 1994?
Offer a very short reply. 0.86. What is the difference between the Female students (as % of total students) in Primary education in 1992 and the Female students (as % of total students) in Secondary general education in 1994?
Your answer should be compact. -2.31. What is the difference between the Female students (as % of total students) in Primary education in 1992 and the Female students (as % of total students) in Secondary vocational education in 1994?
Ensure brevity in your answer.  11.18. What is the difference between the Female students (as % of total students) in Tertiary education in 1992 and the Female students (as % of total students) in Secondary general education in 1994?
Your answer should be very brief. -3.13. What is the difference between the Female students (as % of total students) of Tertiary education in 1992 and the Female students (as % of total students) of Secondary vocational education in 1994?
Give a very brief answer. 10.35. What is the difference between the Female students (as % of total students) in Secondary general education in 1992 and the Female students (as % of total students) in Secondary vocational education in 1994?
Make the answer very short. 13.28. What is the difference between the Female students (as % of total students) of Primary education in 1992 and the Female students (as % of total students) of Tertiary education in 1995?
Your response must be concise. 0.91. What is the difference between the Female students (as % of total students) of Primary education in 1992 and the Female students (as % of total students) of Secondary general education in 1995?
Make the answer very short. -1.77. What is the difference between the Female students (as % of total students) of Primary education in 1992 and the Female students (as % of total students) of Secondary vocational education in 1995?
Provide a short and direct response. 11.04. What is the difference between the Female students (as % of total students) in Tertiary education in 1992 and the Female students (as % of total students) in Secondary general education in 1995?
Your response must be concise. -2.59. What is the difference between the Female students (as % of total students) of Tertiary education in 1992 and the Female students (as % of total students) of Secondary vocational education in 1995?
Make the answer very short. 10.22. What is the difference between the Female students (as % of total students) of Secondary general education in 1992 and the Female students (as % of total students) of Secondary vocational education in 1995?
Your answer should be very brief. 13.15. What is the difference between the Female students (as % of total students) of Primary education in 1992 and the Female students (as % of total students) of Tertiary education in 1999?
Your answer should be compact. 0.91. What is the difference between the Female students (as % of total students) of Primary education in 1992 and the Female students (as % of total students) of Secondary general education in 1999?
Keep it short and to the point. -1.65. What is the difference between the Female students (as % of total students) in Primary education in 1992 and the Female students (as % of total students) in Secondary vocational education in 1999?
Your answer should be very brief. 10.1. What is the difference between the Female students (as % of total students) in Tertiary education in 1992 and the Female students (as % of total students) in Secondary general education in 1999?
Ensure brevity in your answer.  -2.47. What is the difference between the Female students (as % of total students) of Tertiary education in 1992 and the Female students (as % of total students) of Secondary vocational education in 1999?
Ensure brevity in your answer.  9.28. What is the difference between the Female students (as % of total students) in Secondary general education in 1992 and the Female students (as % of total students) in Secondary vocational education in 1999?
Offer a very short reply. 12.21. What is the difference between the Female students (as % of total students) of Primary education in 1993 and the Female students (as % of total students) of Tertiary education in 1994?
Offer a very short reply. 0.86. What is the difference between the Female students (as % of total students) of Primary education in 1993 and the Female students (as % of total students) of Secondary general education in 1994?
Provide a succinct answer. -2.31. What is the difference between the Female students (as % of total students) of Primary education in 1993 and the Female students (as % of total students) of Secondary vocational education in 1994?
Offer a terse response. 11.18. What is the difference between the Female students (as % of total students) of Tertiary education in 1993 and the Female students (as % of total students) of Secondary general education in 1994?
Ensure brevity in your answer.  -3.31. What is the difference between the Female students (as % of total students) of Tertiary education in 1993 and the Female students (as % of total students) of Secondary vocational education in 1994?
Keep it short and to the point. 10.18. What is the difference between the Female students (as % of total students) of Secondary general education in 1993 and the Female students (as % of total students) of Secondary vocational education in 1994?
Give a very brief answer. 13.43. What is the difference between the Female students (as % of total students) of Primary education in 1993 and the Female students (as % of total students) of Tertiary education in 1995?
Ensure brevity in your answer.  0.91. What is the difference between the Female students (as % of total students) in Primary education in 1993 and the Female students (as % of total students) in Secondary general education in 1995?
Your answer should be very brief. -1.77. What is the difference between the Female students (as % of total students) of Primary education in 1993 and the Female students (as % of total students) of Secondary vocational education in 1995?
Give a very brief answer. 11.04. What is the difference between the Female students (as % of total students) of Tertiary education in 1993 and the Female students (as % of total students) of Secondary general education in 1995?
Keep it short and to the point. -2.76. What is the difference between the Female students (as % of total students) of Tertiary education in 1993 and the Female students (as % of total students) of Secondary vocational education in 1995?
Your response must be concise. 10.04. What is the difference between the Female students (as % of total students) in Secondary general education in 1993 and the Female students (as % of total students) in Secondary vocational education in 1995?
Your response must be concise. 13.29. What is the difference between the Female students (as % of total students) in Primary education in 1993 and the Female students (as % of total students) in Tertiary education in 1999?
Your answer should be compact. 0.91. What is the difference between the Female students (as % of total students) of Primary education in 1993 and the Female students (as % of total students) of Secondary general education in 1999?
Make the answer very short. -1.65. What is the difference between the Female students (as % of total students) of Primary education in 1993 and the Female students (as % of total students) of Secondary vocational education in 1999?
Provide a succinct answer. 10.1. What is the difference between the Female students (as % of total students) in Tertiary education in 1993 and the Female students (as % of total students) in Secondary general education in 1999?
Your response must be concise. -2.65. What is the difference between the Female students (as % of total students) in Tertiary education in 1993 and the Female students (as % of total students) in Secondary vocational education in 1999?
Provide a short and direct response. 9.1. What is the difference between the Female students (as % of total students) of Secondary general education in 1993 and the Female students (as % of total students) of Secondary vocational education in 1999?
Offer a terse response. 12.35. What is the difference between the Female students (as % of total students) in Primary education in 1994 and the Female students (as % of total students) in Tertiary education in 1995?
Make the answer very short. 0.81. What is the difference between the Female students (as % of total students) of Primary education in 1994 and the Female students (as % of total students) of Secondary general education in 1995?
Offer a very short reply. -1.87. What is the difference between the Female students (as % of total students) in Primary education in 1994 and the Female students (as % of total students) in Secondary vocational education in 1995?
Your answer should be very brief. 10.94. What is the difference between the Female students (as % of total students) in Tertiary education in 1994 and the Female students (as % of total students) in Secondary general education in 1995?
Ensure brevity in your answer.  -2.62. What is the difference between the Female students (as % of total students) of Tertiary education in 1994 and the Female students (as % of total students) of Secondary vocational education in 1995?
Keep it short and to the point. 10.19. What is the difference between the Female students (as % of total students) of Secondary general education in 1994 and the Female students (as % of total students) of Secondary vocational education in 1995?
Make the answer very short. 13.35. What is the difference between the Female students (as % of total students) in Primary education in 1994 and the Female students (as % of total students) in Tertiary education in 1999?
Provide a short and direct response. 0.81. What is the difference between the Female students (as % of total students) of Primary education in 1994 and the Female students (as % of total students) of Secondary general education in 1999?
Your response must be concise. -1.75. What is the difference between the Female students (as % of total students) in Primary education in 1994 and the Female students (as % of total students) in Secondary vocational education in 1999?
Offer a terse response. 10. What is the difference between the Female students (as % of total students) of Tertiary education in 1994 and the Female students (as % of total students) of Secondary general education in 1999?
Give a very brief answer. -2.51. What is the difference between the Female students (as % of total students) of Tertiary education in 1994 and the Female students (as % of total students) of Secondary vocational education in 1999?
Make the answer very short. 9.25. What is the difference between the Female students (as % of total students) in Secondary general education in 1994 and the Female students (as % of total students) in Secondary vocational education in 1999?
Provide a succinct answer. 12.41. What is the difference between the Female students (as % of total students) of Primary education in 1995 and the Female students (as % of total students) of Tertiary education in 1999?
Your response must be concise. 0.54. What is the difference between the Female students (as % of total students) in Primary education in 1995 and the Female students (as % of total students) in Secondary general education in 1999?
Ensure brevity in your answer.  -2.03. What is the difference between the Female students (as % of total students) in Primary education in 1995 and the Female students (as % of total students) in Secondary vocational education in 1999?
Your answer should be compact. 9.72. What is the difference between the Female students (as % of total students) of Tertiary education in 1995 and the Female students (as % of total students) of Secondary general education in 1999?
Provide a short and direct response. -2.56. What is the difference between the Female students (as % of total students) in Tertiary education in 1995 and the Female students (as % of total students) in Secondary vocational education in 1999?
Provide a short and direct response. 9.19. What is the difference between the Female students (as % of total students) of Secondary general education in 1995 and the Female students (as % of total students) of Secondary vocational education in 1999?
Offer a terse response. 11.87. What is the average Female students (as % of total students) in Primary education per year?
Your answer should be very brief. 49.06. What is the average Female students (as % of total students) of Tertiary education per year?
Your answer should be very brief. 48.43. What is the average Female students (as % of total students) in Secondary general education per year?
Give a very brief answer. 50.88. What is the average Female students (as % of total students) of Secondary vocational education per year?
Your response must be concise. 37.58. In the year 1989, what is the difference between the Female students (as % of total students) of Primary education and Female students (as % of total students) of Tertiary education?
Your response must be concise. 0.41. In the year 1989, what is the difference between the Female students (as % of total students) of Primary education and Female students (as % of total students) of Secondary general education?
Keep it short and to the point. -0.77. In the year 1989, what is the difference between the Female students (as % of total students) in Primary education and Female students (as % of total students) in Secondary vocational education?
Keep it short and to the point. 11.99. In the year 1989, what is the difference between the Female students (as % of total students) in Tertiary education and Female students (as % of total students) in Secondary general education?
Offer a terse response. -1.18. In the year 1989, what is the difference between the Female students (as % of total students) in Tertiary education and Female students (as % of total students) in Secondary vocational education?
Offer a very short reply. 11.58. In the year 1989, what is the difference between the Female students (as % of total students) of Secondary general education and Female students (as % of total students) of Secondary vocational education?
Give a very brief answer. 12.76. In the year 1990, what is the difference between the Female students (as % of total students) in Primary education and Female students (as % of total students) in Tertiary education?
Provide a succinct answer. 0.55. In the year 1990, what is the difference between the Female students (as % of total students) of Primary education and Female students (as % of total students) of Secondary general education?
Your answer should be very brief. -0.82. In the year 1990, what is the difference between the Female students (as % of total students) of Primary education and Female students (as % of total students) of Secondary vocational education?
Give a very brief answer. 12.05. In the year 1990, what is the difference between the Female students (as % of total students) of Tertiary education and Female students (as % of total students) of Secondary general education?
Make the answer very short. -1.38. In the year 1990, what is the difference between the Female students (as % of total students) in Tertiary education and Female students (as % of total students) in Secondary vocational education?
Offer a terse response. 11.5. In the year 1990, what is the difference between the Female students (as % of total students) in Secondary general education and Female students (as % of total students) in Secondary vocational education?
Provide a succinct answer. 12.88. In the year 1991, what is the difference between the Female students (as % of total students) of Primary education and Female students (as % of total students) of Tertiary education?
Provide a succinct answer. 0.71. In the year 1991, what is the difference between the Female students (as % of total students) of Primary education and Female students (as % of total students) of Secondary general education?
Ensure brevity in your answer.  -1.76. In the year 1991, what is the difference between the Female students (as % of total students) of Primary education and Female students (as % of total students) of Secondary vocational education?
Offer a terse response. 12.09. In the year 1991, what is the difference between the Female students (as % of total students) in Tertiary education and Female students (as % of total students) in Secondary general education?
Give a very brief answer. -2.47. In the year 1991, what is the difference between the Female students (as % of total students) in Tertiary education and Female students (as % of total students) in Secondary vocational education?
Offer a very short reply. 11.38. In the year 1991, what is the difference between the Female students (as % of total students) in Secondary general education and Female students (as % of total students) in Secondary vocational education?
Your answer should be compact. 13.86. In the year 1992, what is the difference between the Female students (as % of total students) in Primary education and Female students (as % of total students) in Tertiary education?
Offer a terse response. 0.82. In the year 1992, what is the difference between the Female students (as % of total students) of Primary education and Female students (as % of total students) of Secondary general education?
Provide a short and direct response. -2.1. In the year 1992, what is the difference between the Female students (as % of total students) in Primary education and Female students (as % of total students) in Secondary vocational education?
Your answer should be very brief. 12.43. In the year 1992, what is the difference between the Female students (as % of total students) in Tertiary education and Female students (as % of total students) in Secondary general education?
Provide a succinct answer. -2.93. In the year 1992, what is the difference between the Female students (as % of total students) of Tertiary education and Female students (as % of total students) of Secondary vocational education?
Keep it short and to the point. 11.6. In the year 1992, what is the difference between the Female students (as % of total students) in Secondary general education and Female students (as % of total students) in Secondary vocational education?
Provide a short and direct response. 14.53. In the year 1993, what is the difference between the Female students (as % of total students) in Primary education and Female students (as % of total students) in Tertiary education?
Provide a succinct answer. 1. In the year 1993, what is the difference between the Female students (as % of total students) of Primary education and Female students (as % of total students) of Secondary general education?
Give a very brief answer. -2.25. In the year 1993, what is the difference between the Female students (as % of total students) in Primary education and Female students (as % of total students) in Secondary vocational education?
Ensure brevity in your answer.  12.04. In the year 1993, what is the difference between the Female students (as % of total students) of Tertiary education and Female students (as % of total students) of Secondary general education?
Offer a terse response. -3.25. In the year 1993, what is the difference between the Female students (as % of total students) in Tertiary education and Female students (as % of total students) in Secondary vocational education?
Your answer should be compact. 11.05. In the year 1993, what is the difference between the Female students (as % of total students) of Secondary general education and Female students (as % of total students) of Secondary vocational education?
Offer a very short reply. 14.29. In the year 1994, what is the difference between the Female students (as % of total students) of Primary education and Female students (as % of total students) of Tertiary education?
Give a very brief answer. 0.75. In the year 1994, what is the difference between the Female students (as % of total students) of Primary education and Female students (as % of total students) of Secondary general education?
Your response must be concise. -2.41. In the year 1994, what is the difference between the Female students (as % of total students) in Primary education and Female students (as % of total students) in Secondary vocational education?
Ensure brevity in your answer.  11.07. In the year 1994, what is the difference between the Female students (as % of total students) in Tertiary education and Female students (as % of total students) in Secondary general education?
Your answer should be compact. -3.16. In the year 1994, what is the difference between the Female students (as % of total students) in Tertiary education and Female students (as % of total students) in Secondary vocational education?
Your response must be concise. 10.32. In the year 1994, what is the difference between the Female students (as % of total students) of Secondary general education and Female students (as % of total students) of Secondary vocational education?
Give a very brief answer. 13.48. In the year 1995, what is the difference between the Female students (as % of total students) of Primary education and Female students (as % of total students) of Tertiary education?
Provide a succinct answer. 0.53. In the year 1995, what is the difference between the Female students (as % of total students) of Primary education and Female students (as % of total students) of Secondary general education?
Keep it short and to the point. -2.14. In the year 1995, what is the difference between the Female students (as % of total students) of Primary education and Female students (as % of total students) of Secondary vocational education?
Your answer should be compact. 10.67. In the year 1995, what is the difference between the Female students (as % of total students) in Tertiary education and Female students (as % of total students) in Secondary general education?
Ensure brevity in your answer.  -2.67. In the year 1995, what is the difference between the Female students (as % of total students) in Tertiary education and Female students (as % of total students) in Secondary vocational education?
Provide a short and direct response. 10.13. In the year 1995, what is the difference between the Female students (as % of total students) of Secondary general education and Female students (as % of total students) of Secondary vocational education?
Keep it short and to the point. 12.81. In the year 1999, what is the difference between the Female students (as % of total students) of Primary education and Female students (as % of total students) of Tertiary education?
Provide a succinct answer. 0.25. In the year 1999, what is the difference between the Female students (as % of total students) of Primary education and Female students (as % of total students) of Secondary general education?
Offer a very short reply. -2.31. In the year 1999, what is the difference between the Female students (as % of total students) of Primary education and Female students (as % of total students) of Secondary vocational education?
Give a very brief answer. 9.44. In the year 1999, what is the difference between the Female students (as % of total students) in Tertiary education and Female students (as % of total students) in Secondary general education?
Offer a very short reply. -2.56. In the year 1999, what is the difference between the Female students (as % of total students) of Tertiary education and Female students (as % of total students) of Secondary vocational education?
Your response must be concise. 9.19. In the year 1999, what is the difference between the Female students (as % of total students) in Secondary general education and Female students (as % of total students) in Secondary vocational education?
Keep it short and to the point. 11.75. What is the ratio of the Female students (as % of total students) of Tertiary education in 1989 to that in 1990?
Your response must be concise. 1. What is the ratio of the Female students (as % of total students) of Secondary general education in 1989 to that in 1990?
Provide a short and direct response. 1. What is the ratio of the Female students (as % of total students) of Secondary vocational education in 1989 to that in 1990?
Keep it short and to the point. 1. What is the ratio of the Female students (as % of total students) of Tertiary education in 1989 to that in 1991?
Offer a very short reply. 1.01. What is the ratio of the Female students (as % of total students) in Secondary general education in 1989 to that in 1991?
Your answer should be very brief. 0.98. What is the ratio of the Female students (as % of total students) in Secondary vocational education in 1989 to that in 1991?
Your answer should be very brief. 1. What is the ratio of the Female students (as % of total students) in Tertiary education in 1989 to that in 1992?
Keep it short and to the point. 1.01. What is the ratio of the Female students (as % of total students) in Secondary general education in 1989 to that in 1992?
Give a very brief answer. 0.97. What is the ratio of the Female students (as % of total students) in Secondary vocational education in 1989 to that in 1992?
Your response must be concise. 1.01. What is the ratio of the Female students (as % of total students) of Primary education in 1989 to that in 1993?
Offer a very short reply. 1. What is the ratio of the Female students (as % of total students) of Tertiary education in 1989 to that in 1993?
Give a very brief answer. 1.01. What is the ratio of the Female students (as % of total students) in Secondary general education in 1989 to that in 1993?
Your response must be concise. 0.97. What is the ratio of the Female students (as % of total students) in Tertiary education in 1989 to that in 1994?
Your answer should be very brief. 1.01. What is the ratio of the Female students (as % of total students) of Secondary general education in 1989 to that in 1994?
Make the answer very short. 0.97. What is the ratio of the Female students (as % of total students) of Secondary vocational education in 1989 to that in 1994?
Provide a succinct answer. 0.98. What is the ratio of the Female students (as % of total students) of Primary education in 1989 to that in 1995?
Offer a terse response. 1.01. What is the ratio of the Female students (as % of total students) in Tertiary education in 1989 to that in 1995?
Give a very brief answer. 1.01. What is the ratio of the Female students (as % of total students) in Secondary general education in 1989 to that in 1995?
Offer a very short reply. 0.98. What is the ratio of the Female students (as % of total students) of Secondary vocational education in 1989 to that in 1995?
Your answer should be very brief. 0.98. What is the ratio of the Female students (as % of total students) in Primary education in 1989 to that in 1999?
Your answer should be very brief. 1.01. What is the ratio of the Female students (as % of total students) in Tertiary education in 1989 to that in 1999?
Keep it short and to the point. 1.01. What is the ratio of the Female students (as % of total students) in Secondary general education in 1989 to that in 1999?
Keep it short and to the point. 0.98. What is the ratio of the Female students (as % of total students) of Secondary vocational education in 1989 to that in 1999?
Make the answer very short. 0.95. What is the ratio of the Female students (as % of total students) of Primary education in 1990 to that in 1991?
Offer a very short reply. 1. What is the ratio of the Female students (as % of total students) in Tertiary education in 1990 to that in 1991?
Provide a short and direct response. 1. What is the ratio of the Female students (as % of total students) of Secondary general education in 1990 to that in 1991?
Offer a very short reply. 0.98. What is the ratio of the Female students (as % of total students) of Secondary vocational education in 1990 to that in 1991?
Your answer should be compact. 1. What is the ratio of the Female students (as % of total students) in Primary education in 1990 to that in 1992?
Provide a succinct answer. 1. What is the ratio of the Female students (as % of total students) of Tertiary education in 1990 to that in 1992?
Offer a terse response. 1.01. What is the ratio of the Female students (as % of total students) of Secondary general education in 1990 to that in 1992?
Make the answer very short. 0.98. What is the ratio of the Female students (as % of total students) in Secondary vocational education in 1990 to that in 1992?
Offer a terse response. 1.01. What is the ratio of the Female students (as % of total students) of Tertiary education in 1990 to that in 1993?
Provide a short and direct response. 1.01. What is the ratio of the Female students (as % of total students) of Secondary general education in 1990 to that in 1993?
Give a very brief answer. 0.97. What is the ratio of the Female students (as % of total students) in Secondary vocational education in 1990 to that in 1993?
Offer a terse response. 1. What is the ratio of the Female students (as % of total students) in Tertiary education in 1990 to that in 1994?
Offer a very short reply. 1.01. What is the ratio of the Female students (as % of total students) in Secondary general education in 1990 to that in 1994?
Offer a terse response. 0.97. What is the ratio of the Female students (as % of total students) of Primary education in 1990 to that in 1995?
Your response must be concise. 1.01. What is the ratio of the Female students (as % of total students) in Tertiary education in 1990 to that in 1995?
Ensure brevity in your answer.  1.01. What is the ratio of the Female students (as % of total students) of Secondary general education in 1990 to that in 1995?
Your answer should be very brief. 0.98. What is the ratio of the Female students (as % of total students) of Secondary vocational education in 1990 to that in 1995?
Ensure brevity in your answer.  0.97. What is the ratio of the Female students (as % of total students) of Primary education in 1990 to that in 1999?
Provide a short and direct response. 1.01. What is the ratio of the Female students (as % of total students) in Tertiary education in 1990 to that in 1999?
Make the answer very short. 1.01. What is the ratio of the Female students (as % of total students) of Secondary general education in 1990 to that in 1999?
Your response must be concise. 0.98. What is the ratio of the Female students (as % of total students) in Secondary vocational education in 1990 to that in 1999?
Your answer should be compact. 0.95. What is the ratio of the Female students (as % of total students) of Secondary general education in 1991 to that in 1992?
Your answer should be very brief. 0.99. What is the ratio of the Female students (as % of total students) of Secondary general education in 1991 to that in 1993?
Provide a succinct answer. 0.99. What is the ratio of the Female students (as % of total students) of Secondary vocational education in 1991 to that in 1993?
Provide a short and direct response. 1. What is the ratio of the Female students (as % of total students) of Tertiary education in 1991 to that in 1994?
Your response must be concise. 1. What is the ratio of the Female students (as % of total students) of Secondary general education in 1991 to that in 1994?
Offer a terse response. 0.99. What is the ratio of the Female students (as % of total students) in Secondary vocational education in 1991 to that in 1994?
Ensure brevity in your answer.  0.98. What is the ratio of the Female students (as % of total students) of Primary education in 1991 to that in 1995?
Provide a short and direct response. 1.01. What is the ratio of the Female students (as % of total students) of Tertiary education in 1991 to that in 1995?
Keep it short and to the point. 1. What is the ratio of the Female students (as % of total students) of Secondary vocational education in 1991 to that in 1995?
Offer a terse response. 0.97. What is the ratio of the Female students (as % of total students) of Primary education in 1991 to that in 1999?
Provide a short and direct response. 1.01. What is the ratio of the Female students (as % of total students) in Secondary vocational education in 1991 to that in 1999?
Offer a very short reply. 0.95. What is the ratio of the Female students (as % of total students) of Primary education in 1992 to that in 1993?
Keep it short and to the point. 1. What is the ratio of the Female students (as % of total students) in Tertiary education in 1992 to that in 1993?
Make the answer very short. 1. What is the ratio of the Female students (as % of total students) of Secondary general education in 1992 to that in 1993?
Ensure brevity in your answer.  1. What is the ratio of the Female students (as % of total students) of Secondary general education in 1992 to that in 1994?
Ensure brevity in your answer.  1. What is the ratio of the Female students (as % of total students) in Secondary vocational education in 1992 to that in 1994?
Provide a short and direct response. 0.97. What is the ratio of the Female students (as % of total students) of Primary education in 1992 to that in 1995?
Your answer should be very brief. 1.01. What is the ratio of the Female students (as % of total students) in Tertiary education in 1992 to that in 1995?
Your answer should be very brief. 1. What is the ratio of the Female students (as % of total students) of Secondary general education in 1992 to that in 1995?
Make the answer very short. 1.01. What is the ratio of the Female students (as % of total students) in Secondary vocational education in 1992 to that in 1995?
Your answer should be compact. 0.96. What is the ratio of the Female students (as % of total students) in Primary education in 1992 to that in 1999?
Make the answer very short. 1.01. What is the ratio of the Female students (as % of total students) in Secondary general education in 1992 to that in 1999?
Provide a succinct answer. 1.01. What is the ratio of the Female students (as % of total students) in Secondary vocational education in 1992 to that in 1999?
Give a very brief answer. 0.94. What is the ratio of the Female students (as % of total students) in Tertiary education in 1993 to that in 1994?
Ensure brevity in your answer.  1. What is the ratio of the Female students (as % of total students) of Secondary vocational education in 1993 to that in 1994?
Keep it short and to the point. 0.98. What is the ratio of the Female students (as % of total students) in Primary education in 1993 to that in 1995?
Provide a succinct answer. 1.01. What is the ratio of the Female students (as % of total students) in Tertiary education in 1993 to that in 1995?
Your response must be concise. 1. What is the ratio of the Female students (as % of total students) in Secondary general education in 1993 to that in 1995?
Your response must be concise. 1.01. What is the ratio of the Female students (as % of total students) of Secondary vocational education in 1993 to that in 1995?
Offer a terse response. 0.97. What is the ratio of the Female students (as % of total students) in Primary education in 1993 to that in 1999?
Give a very brief answer. 1.01. What is the ratio of the Female students (as % of total students) in Tertiary education in 1993 to that in 1999?
Provide a short and direct response. 1. What is the ratio of the Female students (as % of total students) of Secondary general education in 1993 to that in 1999?
Your answer should be very brief. 1.01. What is the ratio of the Female students (as % of total students) of Secondary vocational education in 1993 to that in 1999?
Give a very brief answer. 0.95. What is the ratio of the Female students (as % of total students) in Primary education in 1994 to that in 1995?
Offer a very short reply. 1.01. What is the ratio of the Female students (as % of total students) of Secondary general education in 1994 to that in 1995?
Make the answer very short. 1.01. What is the ratio of the Female students (as % of total students) of Secondary vocational education in 1994 to that in 1995?
Your answer should be compact. 1. What is the ratio of the Female students (as % of total students) of Primary education in 1994 to that in 1999?
Offer a terse response. 1.01. What is the ratio of the Female students (as % of total students) of Secondary general education in 1994 to that in 1999?
Make the answer very short. 1.01. What is the ratio of the Female students (as % of total students) of Secondary vocational education in 1994 to that in 1999?
Your answer should be compact. 0.97. What is the ratio of the Female students (as % of total students) of Primary education in 1995 to that in 1999?
Your answer should be very brief. 1.01. What is the ratio of the Female students (as % of total students) in Secondary general education in 1995 to that in 1999?
Give a very brief answer. 1. What is the ratio of the Female students (as % of total students) in Secondary vocational education in 1995 to that in 1999?
Offer a very short reply. 0.98. What is the difference between the highest and the second highest Female students (as % of total students) in Primary education?
Give a very brief answer. 0. What is the difference between the highest and the second highest Female students (as % of total students) of Tertiary education?
Ensure brevity in your answer.  0.14. What is the difference between the highest and the second highest Female students (as % of total students) of Secondary general education?
Make the answer very short. 0.06. What is the difference between the highest and the second highest Female students (as % of total students) in Secondary vocational education?
Offer a very short reply. 0.94. What is the difference between the highest and the lowest Female students (as % of total students) in Primary education?
Provide a succinct answer. 0.67. What is the difference between the highest and the lowest Female students (as % of total students) in Tertiary education?
Your answer should be very brief. 0.59. What is the difference between the highest and the lowest Female students (as % of total students) in Secondary general education?
Offer a very short reply. 1.53. What is the difference between the highest and the lowest Female students (as % of total students) in Secondary vocational education?
Offer a very short reply. 2.32. 